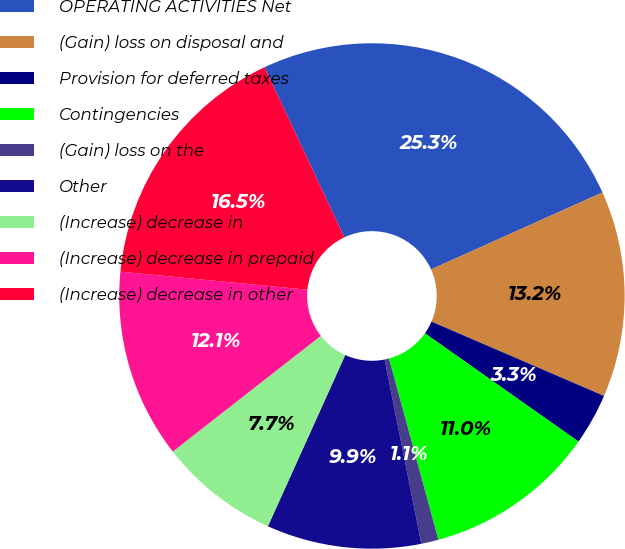Convert chart. <chart><loc_0><loc_0><loc_500><loc_500><pie_chart><fcel>OPERATING ACTIVITIES Net<fcel>(Gain) loss on disposal and<fcel>Provision for deferred taxes<fcel>Contingencies<fcel>(Gain) loss on the<fcel>Other<fcel>(Increase) decrease in<fcel>(Increase) decrease in prepaid<fcel>(Increase) decrease in other<nl><fcel>25.27%<fcel>13.19%<fcel>3.3%<fcel>10.99%<fcel>1.1%<fcel>9.89%<fcel>7.69%<fcel>12.09%<fcel>16.48%<nl></chart> 